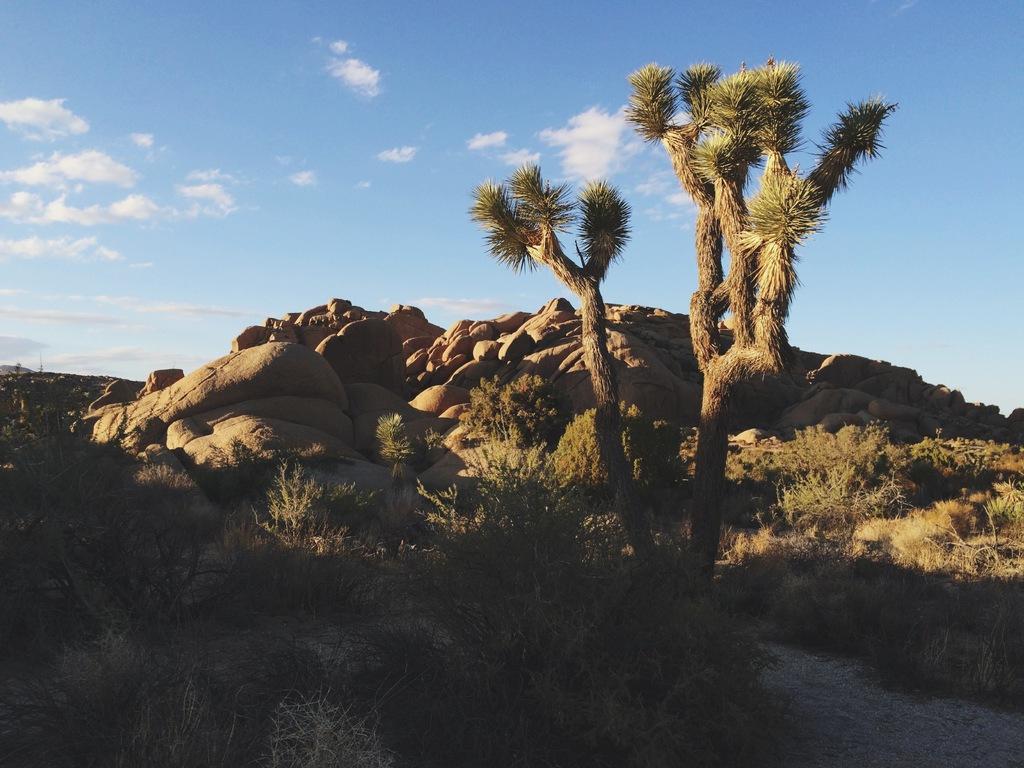Could you give a brief overview of what you see in this image? Sky is in blue color. These are clouds. Here we can see a tree, plants and rocks.  